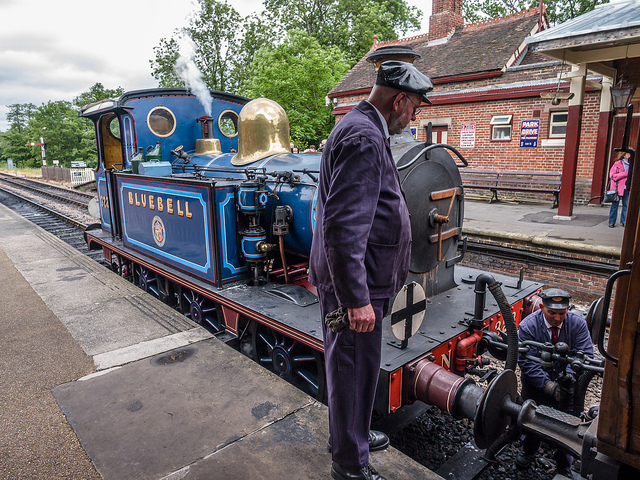Read all the text in this image. BLUEBELL PARK 